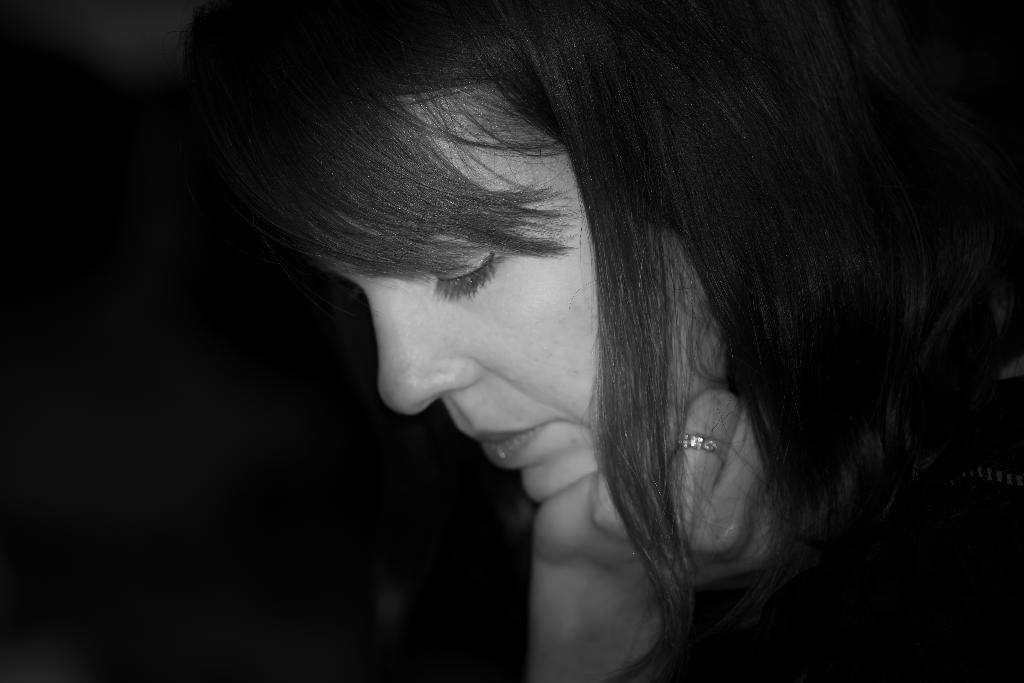Who is present in the image? There is a woman in the image. What can be seen behind the woman? The background of the image is black. What type of wine is the woman holding in the image? There is no wine present in the image; the woman is not holding any wine. How many zebras can be seen in the image? There are no zebras present in the image. 